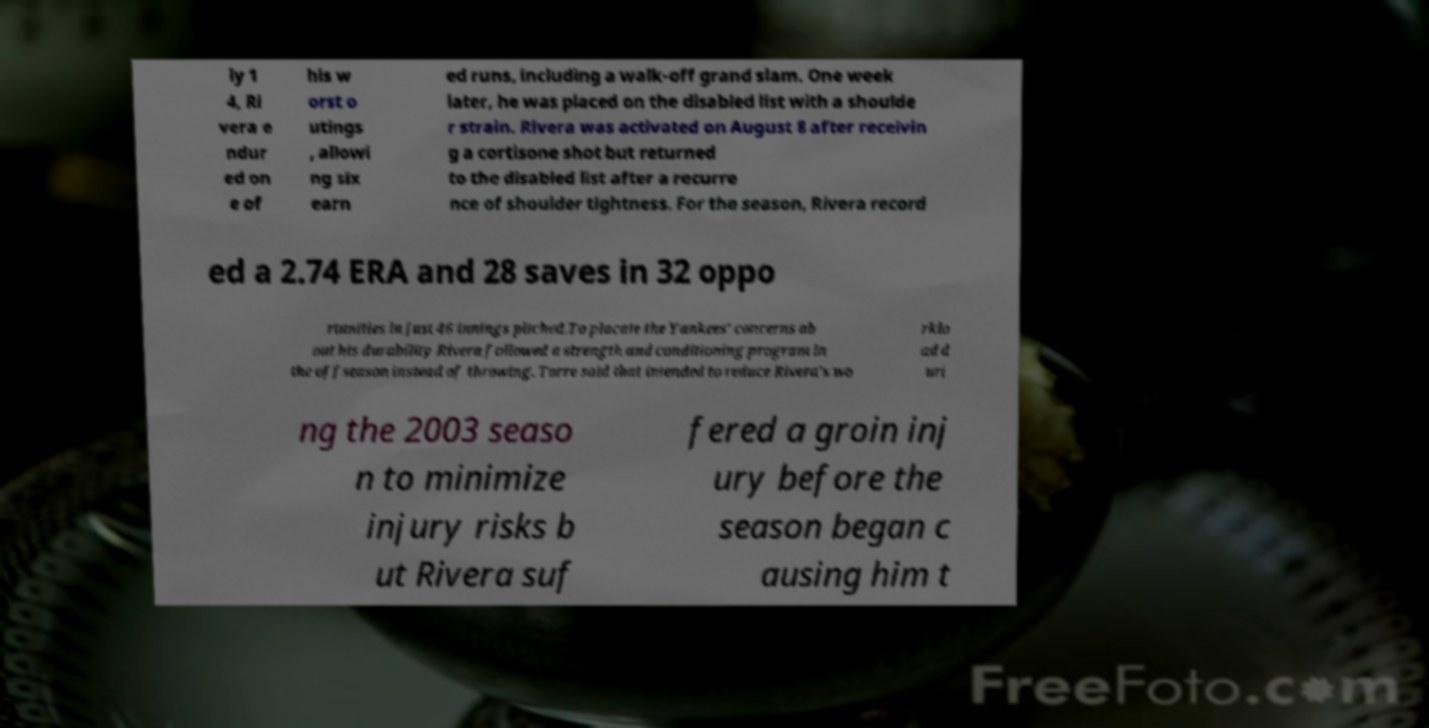For documentation purposes, I need the text within this image transcribed. Could you provide that? ly 1 4, Ri vera e ndur ed on e of his w orst o utings , allowi ng six earn ed runs, including a walk-off grand slam. One week later, he was placed on the disabled list with a shoulde r strain. Rivera was activated on August 8 after receivin g a cortisone shot but returned to the disabled list after a recurre nce of shoulder tightness. For the season, Rivera record ed a 2.74 ERA and 28 saves in 32 oppo rtunities in just 46 innings pitched.To placate the Yankees' concerns ab out his durability Rivera followed a strength and conditioning program in the offseason instead of throwing. Torre said that intended to reduce Rivera's wo rklo ad d uri ng the 2003 seaso n to minimize injury risks b ut Rivera suf fered a groin inj ury before the season began c ausing him t 